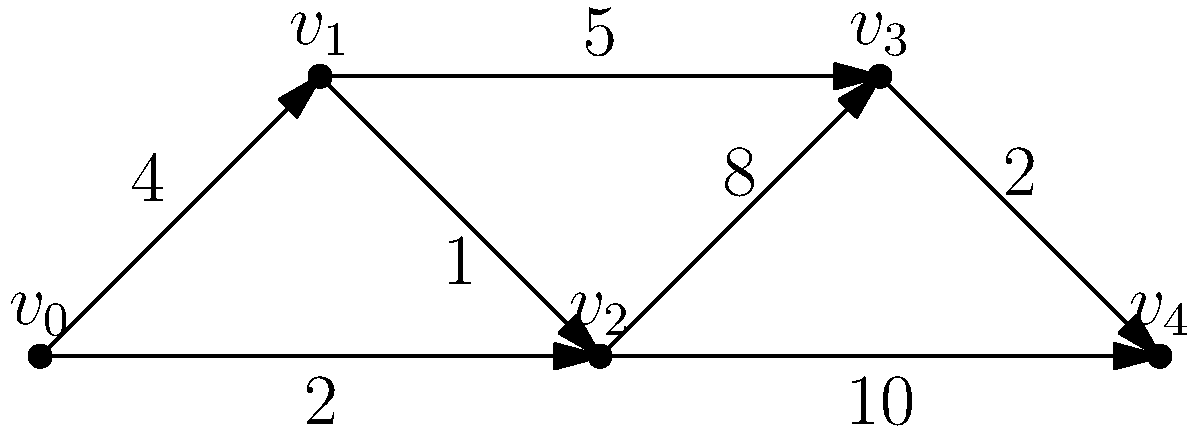Given the weighted directed graph above, apply Dijkstra's algorithm to find the shortest path from vertex $v_0$ to vertex $v_4$. What is the total weight of this shortest path? Let's apply Dijkstra's algorithm step by step:

1) Initialize:
   - Set distance to $v_0$ as 0
   - Set distances to all other vertices as $\infty$
   - Set all vertices as unvisited

2) Start from $v_0$:
   - Update distances: $d(v_1) = 4$, $d(v_2) = 2$
   - Mark $v_0$ as visited

3) Select the unvisited vertex with the smallest distance: $v_2$
   - Update distances: $d(v_3) = \min(∞, 2+8) = 10$, $d(v_4) = \min(∞, 2+10) = 12$
   - Mark $v_2$ as visited

4) Select the unvisited vertex with the smallest distance: $v_1$
   - Update distances: $d(v_3) = \min(10, 4+5) = 9$
   - Mark $v_1$ as visited

5) Select the unvisited vertex with the smallest distance: $v_3$
   - Update distances: $d(v_4) = \min(12, 9+2) = 11$
   - Mark $v_3$ as visited

6) $v_4$ is the only unvisited vertex left, so we're done.

The shortest path is $v_0 \to v_2 \to v_1 \to v_3 \to v_4$ with a total weight of 11.
Answer: 11 